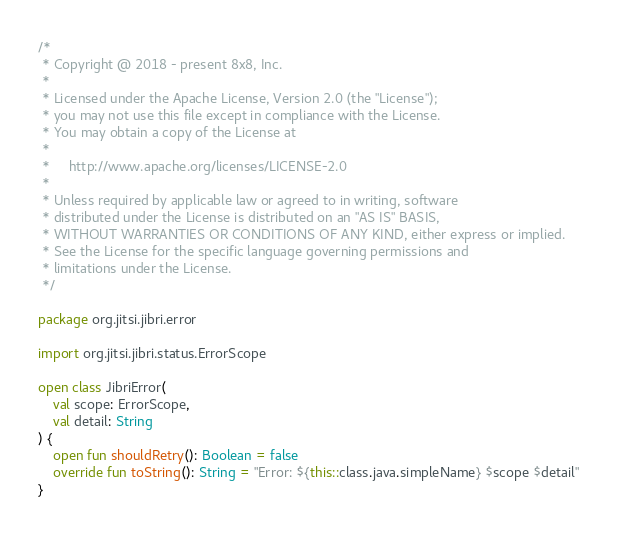<code> <loc_0><loc_0><loc_500><loc_500><_Kotlin_>/*
 * Copyright @ 2018 - present 8x8, Inc.
 *
 * Licensed under the Apache License, Version 2.0 (the "License");
 * you may not use this file except in compliance with the License.
 * You may obtain a copy of the License at
 *
 *     http://www.apache.org/licenses/LICENSE-2.0
 *
 * Unless required by applicable law or agreed to in writing, software
 * distributed under the License is distributed on an "AS IS" BASIS,
 * WITHOUT WARRANTIES OR CONDITIONS OF ANY KIND, either express or implied.
 * See the License for the specific language governing permissions and
 * limitations under the License.
 */

package org.jitsi.jibri.error

import org.jitsi.jibri.status.ErrorScope

open class JibriError(
    val scope: ErrorScope,
    val detail: String
) {
    open fun shouldRetry(): Boolean = false
    override fun toString(): String = "Error: ${this::class.java.simpleName} $scope $detail"
}
</code> 